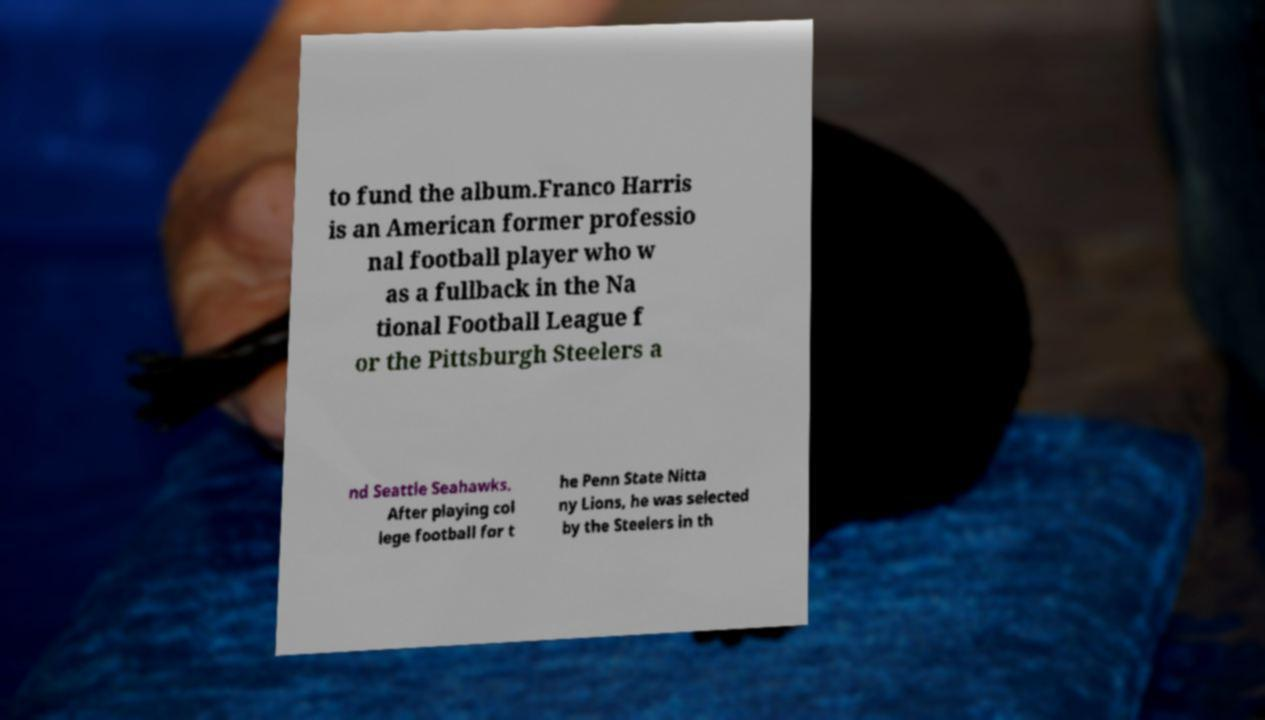What messages or text are displayed in this image? I need them in a readable, typed format. to fund the album.Franco Harris is an American former professio nal football player who w as a fullback in the Na tional Football League f or the Pittsburgh Steelers a nd Seattle Seahawks. After playing col lege football for t he Penn State Nitta ny Lions, he was selected by the Steelers in th 